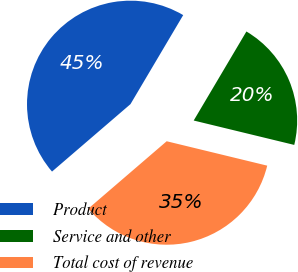Convert chart to OTSL. <chart><loc_0><loc_0><loc_500><loc_500><pie_chart><fcel>Product<fcel>Service and other<fcel>Total cost of revenue<nl><fcel>44.81%<fcel>20.28%<fcel>34.91%<nl></chart> 